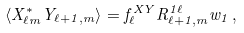Convert formula to latex. <formula><loc_0><loc_0><loc_500><loc_500>\left \langle X _ { \ell m } ^ { * } Y _ { \ell + 1 , m } \right \rangle = f _ { \ell } ^ { X Y } R _ { \ell + 1 , m } ^ { 1 \ell } w _ { 1 } \, ,</formula> 